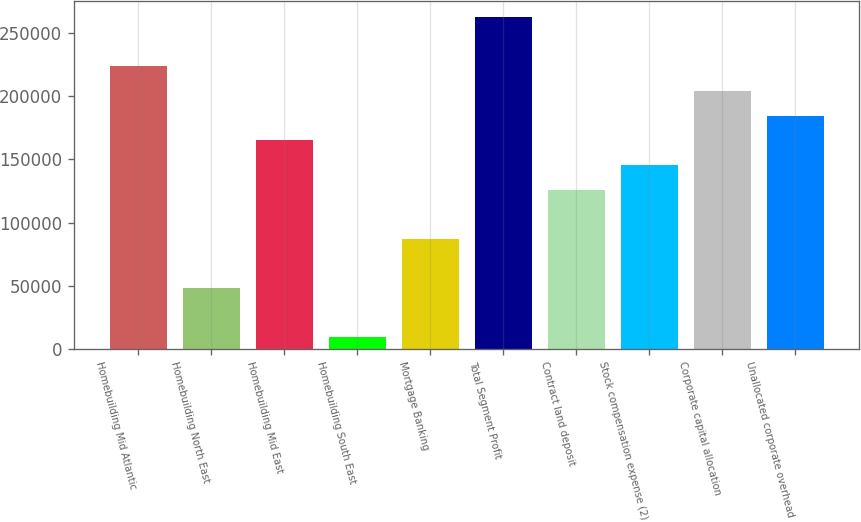Convert chart to OTSL. <chart><loc_0><loc_0><loc_500><loc_500><bar_chart><fcel>Homebuilding Mid Atlantic<fcel>Homebuilding North East<fcel>Homebuilding Mid East<fcel>Homebuilding South East<fcel>Mortgage Banking<fcel>Total Segment Profit<fcel>Contract land deposit<fcel>Stock compensation expense (2)<fcel>Corporate capital allocation<fcel>Unallocated corporate overhead<nl><fcel>223616<fcel>48255<fcel>165162<fcel>9286<fcel>87224<fcel>262584<fcel>126193<fcel>145678<fcel>204131<fcel>184646<nl></chart> 